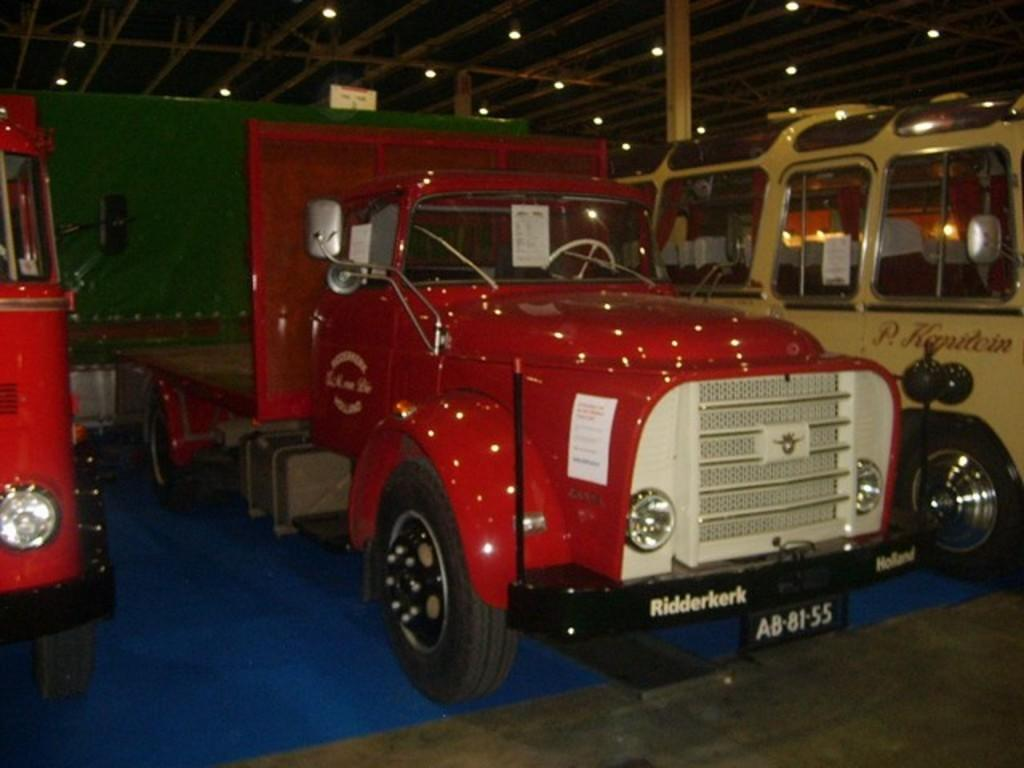How many trucks are visible in the image? There are three trucks in the image. What is the surface on which the trucks are placed? The trucks are on a blue carpet floor. What can be seen on the ceiling in the image? There are lights on the ceiling in the image. What type of wrench is being used to fix the drain in the image? There is no wrench or drain present in the image; it only features three trucks on a blue carpet floor with lights on the ceiling. 